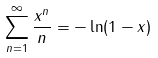<formula> <loc_0><loc_0><loc_500><loc_500>\sum _ { n = 1 } ^ { \infty } \frac { x ^ { n } } { n } = - \ln ( 1 - x ) \\</formula> 